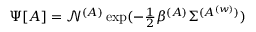<formula> <loc_0><loc_0><loc_500><loc_500>\begin{array} { r } { \Psi [ A ] = \mathcal { N } ^ { ( A ) } \exp ( - \frac { 1 } { 2 } \beta ^ { ( A ) } \Sigma ^ { ( { A ^ { ( w ) } } ) } ) } \end{array}</formula> 